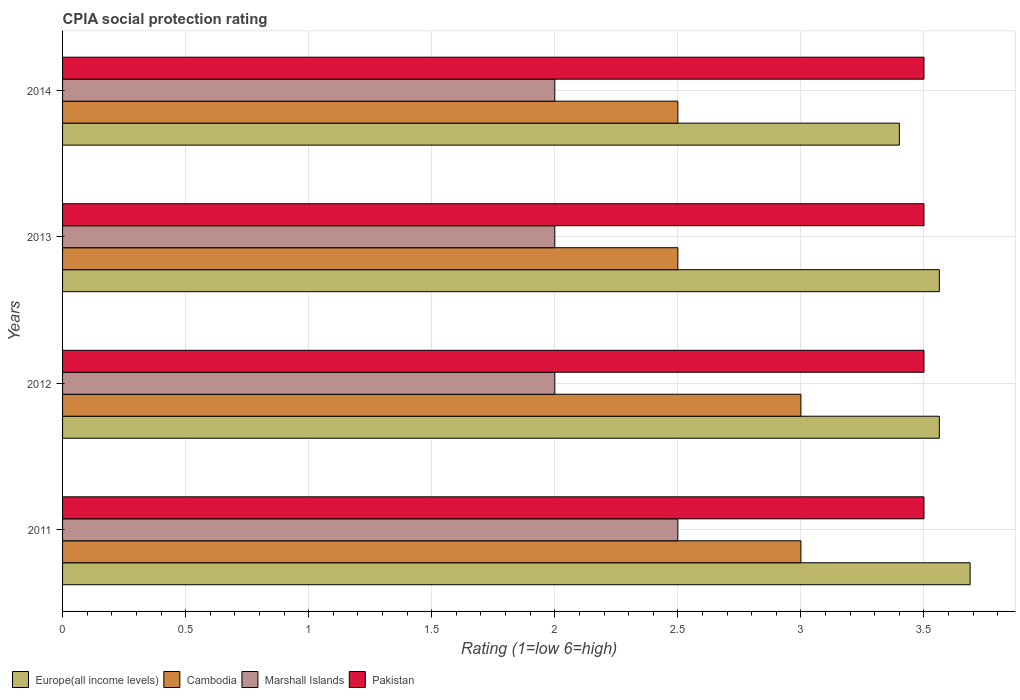How many different coloured bars are there?
Your answer should be very brief. 4. How many bars are there on the 4th tick from the top?
Your response must be concise. 4. What is the label of the 2nd group of bars from the top?
Ensure brevity in your answer.  2013. What is the CPIA rating in Cambodia in 2011?
Make the answer very short. 3. Across all years, what is the maximum CPIA rating in Cambodia?
Your answer should be compact. 3. Across all years, what is the minimum CPIA rating in Europe(all income levels)?
Offer a terse response. 3.4. In which year was the CPIA rating in Pakistan minimum?
Offer a terse response. 2011. What is the difference between the CPIA rating in Europe(all income levels) in 2013 and that in 2014?
Make the answer very short. 0.16. What is the difference between the CPIA rating in Europe(all income levels) in 2014 and the CPIA rating in Pakistan in 2013?
Offer a very short reply. -0.1. What is the average CPIA rating in Europe(all income levels) per year?
Ensure brevity in your answer.  3.55. In the year 2012, what is the difference between the CPIA rating in Europe(all income levels) and CPIA rating in Cambodia?
Offer a very short reply. 0.56. In how many years, is the CPIA rating in Pakistan greater than 2.3 ?
Ensure brevity in your answer.  4. What is the ratio of the CPIA rating in Europe(all income levels) in 2012 to that in 2014?
Make the answer very short. 1.05. Is the CPIA rating in Pakistan in 2011 less than that in 2013?
Your response must be concise. No. Is the difference between the CPIA rating in Europe(all income levels) in 2011 and 2012 greater than the difference between the CPIA rating in Cambodia in 2011 and 2012?
Offer a very short reply. Yes. What does the 3rd bar from the top in 2014 represents?
Offer a terse response. Cambodia. What does the 4th bar from the bottom in 2014 represents?
Offer a very short reply. Pakistan. Is it the case that in every year, the sum of the CPIA rating in Cambodia and CPIA rating in Marshall Islands is greater than the CPIA rating in Europe(all income levels)?
Your response must be concise. Yes. Are all the bars in the graph horizontal?
Your answer should be very brief. Yes. What is the difference between two consecutive major ticks on the X-axis?
Your answer should be compact. 0.5. Does the graph contain any zero values?
Provide a short and direct response. No. Does the graph contain grids?
Make the answer very short. Yes. How are the legend labels stacked?
Make the answer very short. Horizontal. What is the title of the graph?
Your answer should be very brief. CPIA social protection rating. Does "United Arab Emirates" appear as one of the legend labels in the graph?
Your answer should be compact. No. What is the label or title of the X-axis?
Make the answer very short. Rating (1=low 6=high). What is the Rating (1=low 6=high) of Europe(all income levels) in 2011?
Offer a very short reply. 3.69. What is the Rating (1=low 6=high) of Marshall Islands in 2011?
Provide a short and direct response. 2.5. What is the Rating (1=low 6=high) in Europe(all income levels) in 2012?
Offer a very short reply. 3.56. What is the Rating (1=low 6=high) in Pakistan in 2012?
Provide a succinct answer. 3.5. What is the Rating (1=low 6=high) of Europe(all income levels) in 2013?
Give a very brief answer. 3.56. What is the Rating (1=low 6=high) of Marshall Islands in 2013?
Offer a terse response. 2. What is the Rating (1=low 6=high) in Europe(all income levels) in 2014?
Provide a short and direct response. 3.4. What is the Rating (1=low 6=high) in Cambodia in 2014?
Make the answer very short. 2.5. Across all years, what is the maximum Rating (1=low 6=high) in Europe(all income levels)?
Provide a short and direct response. 3.69. Across all years, what is the maximum Rating (1=low 6=high) in Marshall Islands?
Ensure brevity in your answer.  2.5. Across all years, what is the minimum Rating (1=low 6=high) in Europe(all income levels)?
Offer a terse response. 3.4. Across all years, what is the minimum Rating (1=low 6=high) of Marshall Islands?
Keep it short and to the point. 2. Across all years, what is the minimum Rating (1=low 6=high) in Pakistan?
Offer a very short reply. 3.5. What is the total Rating (1=low 6=high) of Europe(all income levels) in the graph?
Make the answer very short. 14.21. What is the total Rating (1=low 6=high) in Marshall Islands in the graph?
Your response must be concise. 8.5. What is the difference between the Rating (1=low 6=high) of Marshall Islands in 2011 and that in 2012?
Offer a terse response. 0.5. What is the difference between the Rating (1=low 6=high) of Cambodia in 2011 and that in 2013?
Provide a short and direct response. 0.5. What is the difference between the Rating (1=low 6=high) in Pakistan in 2011 and that in 2013?
Keep it short and to the point. 0. What is the difference between the Rating (1=low 6=high) in Europe(all income levels) in 2011 and that in 2014?
Your answer should be compact. 0.29. What is the difference between the Rating (1=low 6=high) of Marshall Islands in 2011 and that in 2014?
Offer a very short reply. 0.5. What is the difference between the Rating (1=low 6=high) of Europe(all income levels) in 2012 and that in 2013?
Offer a very short reply. 0. What is the difference between the Rating (1=low 6=high) of Cambodia in 2012 and that in 2013?
Keep it short and to the point. 0.5. What is the difference between the Rating (1=low 6=high) in Pakistan in 2012 and that in 2013?
Your response must be concise. 0. What is the difference between the Rating (1=low 6=high) of Europe(all income levels) in 2012 and that in 2014?
Make the answer very short. 0.16. What is the difference between the Rating (1=low 6=high) in Marshall Islands in 2012 and that in 2014?
Provide a succinct answer. 0. What is the difference between the Rating (1=low 6=high) in Europe(all income levels) in 2013 and that in 2014?
Make the answer very short. 0.16. What is the difference between the Rating (1=low 6=high) of Europe(all income levels) in 2011 and the Rating (1=low 6=high) of Cambodia in 2012?
Provide a short and direct response. 0.69. What is the difference between the Rating (1=low 6=high) in Europe(all income levels) in 2011 and the Rating (1=low 6=high) in Marshall Islands in 2012?
Your response must be concise. 1.69. What is the difference between the Rating (1=low 6=high) in Europe(all income levels) in 2011 and the Rating (1=low 6=high) in Pakistan in 2012?
Your response must be concise. 0.19. What is the difference between the Rating (1=low 6=high) of Marshall Islands in 2011 and the Rating (1=low 6=high) of Pakistan in 2012?
Offer a terse response. -1. What is the difference between the Rating (1=low 6=high) of Europe(all income levels) in 2011 and the Rating (1=low 6=high) of Cambodia in 2013?
Provide a succinct answer. 1.19. What is the difference between the Rating (1=low 6=high) in Europe(all income levels) in 2011 and the Rating (1=low 6=high) in Marshall Islands in 2013?
Provide a short and direct response. 1.69. What is the difference between the Rating (1=low 6=high) in Europe(all income levels) in 2011 and the Rating (1=low 6=high) in Pakistan in 2013?
Your response must be concise. 0.19. What is the difference between the Rating (1=low 6=high) in Cambodia in 2011 and the Rating (1=low 6=high) in Marshall Islands in 2013?
Provide a short and direct response. 1. What is the difference between the Rating (1=low 6=high) in Cambodia in 2011 and the Rating (1=low 6=high) in Pakistan in 2013?
Make the answer very short. -0.5. What is the difference between the Rating (1=low 6=high) in Europe(all income levels) in 2011 and the Rating (1=low 6=high) in Cambodia in 2014?
Your response must be concise. 1.19. What is the difference between the Rating (1=low 6=high) of Europe(all income levels) in 2011 and the Rating (1=low 6=high) of Marshall Islands in 2014?
Ensure brevity in your answer.  1.69. What is the difference between the Rating (1=low 6=high) of Europe(all income levels) in 2011 and the Rating (1=low 6=high) of Pakistan in 2014?
Offer a terse response. 0.19. What is the difference between the Rating (1=low 6=high) in Europe(all income levels) in 2012 and the Rating (1=low 6=high) in Marshall Islands in 2013?
Give a very brief answer. 1.56. What is the difference between the Rating (1=low 6=high) in Europe(all income levels) in 2012 and the Rating (1=low 6=high) in Pakistan in 2013?
Make the answer very short. 0.06. What is the difference between the Rating (1=low 6=high) of Cambodia in 2012 and the Rating (1=low 6=high) of Marshall Islands in 2013?
Give a very brief answer. 1. What is the difference between the Rating (1=low 6=high) of Cambodia in 2012 and the Rating (1=low 6=high) of Pakistan in 2013?
Make the answer very short. -0.5. What is the difference between the Rating (1=low 6=high) of Marshall Islands in 2012 and the Rating (1=low 6=high) of Pakistan in 2013?
Offer a terse response. -1.5. What is the difference between the Rating (1=low 6=high) in Europe(all income levels) in 2012 and the Rating (1=low 6=high) in Marshall Islands in 2014?
Your answer should be very brief. 1.56. What is the difference between the Rating (1=low 6=high) of Europe(all income levels) in 2012 and the Rating (1=low 6=high) of Pakistan in 2014?
Provide a succinct answer. 0.06. What is the difference between the Rating (1=low 6=high) of Marshall Islands in 2012 and the Rating (1=low 6=high) of Pakistan in 2014?
Your response must be concise. -1.5. What is the difference between the Rating (1=low 6=high) in Europe(all income levels) in 2013 and the Rating (1=low 6=high) in Cambodia in 2014?
Ensure brevity in your answer.  1.06. What is the difference between the Rating (1=low 6=high) in Europe(all income levels) in 2013 and the Rating (1=low 6=high) in Marshall Islands in 2014?
Offer a terse response. 1.56. What is the difference between the Rating (1=low 6=high) in Europe(all income levels) in 2013 and the Rating (1=low 6=high) in Pakistan in 2014?
Offer a terse response. 0.06. What is the average Rating (1=low 6=high) in Europe(all income levels) per year?
Provide a succinct answer. 3.55. What is the average Rating (1=low 6=high) of Cambodia per year?
Provide a succinct answer. 2.75. What is the average Rating (1=low 6=high) of Marshall Islands per year?
Offer a very short reply. 2.12. What is the average Rating (1=low 6=high) in Pakistan per year?
Keep it short and to the point. 3.5. In the year 2011, what is the difference between the Rating (1=low 6=high) in Europe(all income levels) and Rating (1=low 6=high) in Cambodia?
Your answer should be compact. 0.69. In the year 2011, what is the difference between the Rating (1=low 6=high) in Europe(all income levels) and Rating (1=low 6=high) in Marshall Islands?
Your answer should be very brief. 1.19. In the year 2011, what is the difference between the Rating (1=low 6=high) of Europe(all income levels) and Rating (1=low 6=high) of Pakistan?
Provide a short and direct response. 0.19. In the year 2011, what is the difference between the Rating (1=low 6=high) of Cambodia and Rating (1=low 6=high) of Marshall Islands?
Provide a short and direct response. 0.5. In the year 2011, what is the difference between the Rating (1=low 6=high) of Cambodia and Rating (1=low 6=high) of Pakistan?
Make the answer very short. -0.5. In the year 2011, what is the difference between the Rating (1=low 6=high) in Marshall Islands and Rating (1=low 6=high) in Pakistan?
Provide a succinct answer. -1. In the year 2012, what is the difference between the Rating (1=low 6=high) of Europe(all income levels) and Rating (1=low 6=high) of Cambodia?
Your answer should be very brief. 0.56. In the year 2012, what is the difference between the Rating (1=low 6=high) of Europe(all income levels) and Rating (1=low 6=high) of Marshall Islands?
Make the answer very short. 1.56. In the year 2012, what is the difference between the Rating (1=low 6=high) in Europe(all income levels) and Rating (1=low 6=high) in Pakistan?
Your answer should be compact. 0.06. In the year 2012, what is the difference between the Rating (1=low 6=high) of Cambodia and Rating (1=low 6=high) of Marshall Islands?
Ensure brevity in your answer.  1. In the year 2012, what is the difference between the Rating (1=low 6=high) in Marshall Islands and Rating (1=low 6=high) in Pakistan?
Your answer should be compact. -1.5. In the year 2013, what is the difference between the Rating (1=low 6=high) of Europe(all income levels) and Rating (1=low 6=high) of Cambodia?
Keep it short and to the point. 1.06. In the year 2013, what is the difference between the Rating (1=low 6=high) of Europe(all income levels) and Rating (1=low 6=high) of Marshall Islands?
Provide a succinct answer. 1.56. In the year 2013, what is the difference between the Rating (1=low 6=high) of Europe(all income levels) and Rating (1=low 6=high) of Pakistan?
Ensure brevity in your answer.  0.06. In the year 2013, what is the difference between the Rating (1=low 6=high) in Cambodia and Rating (1=low 6=high) in Pakistan?
Provide a short and direct response. -1. In the year 2014, what is the difference between the Rating (1=low 6=high) in Europe(all income levels) and Rating (1=low 6=high) in Cambodia?
Ensure brevity in your answer.  0.9. In the year 2014, what is the difference between the Rating (1=low 6=high) of Cambodia and Rating (1=low 6=high) of Marshall Islands?
Keep it short and to the point. 0.5. In the year 2014, what is the difference between the Rating (1=low 6=high) in Marshall Islands and Rating (1=low 6=high) in Pakistan?
Keep it short and to the point. -1.5. What is the ratio of the Rating (1=low 6=high) in Europe(all income levels) in 2011 to that in 2012?
Offer a terse response. 1.04. What is the ratio of the Rating (1=low 6=high) in Cambodia in 2011 to that in 2012?
Make the answer very short. 1. What is the ratio of the Rating (1=low 6=high) in Europe(all income levels) in 2011 to that in 2013?
Give a very brief answer. 1.04. What is the ratio of the Rating (1=low 6=high) of Pakistan in 2011 to that in 2013?
Provide a short and direct response. 1. What is the ratio of the Rating (1=low 6=high) in Europe(all income levels) in 2011 to that in 2014?
Provide a short and direct response. 1.08. What is the ratio of the Rating (1=low 6=high) of Cambodia in 2011 to that in 2014?
Your answer should be compact. 1.2. What is the ratio of the Rating (1=low 6=high) of Cambodia in 2012 to that in 2013?
Your answer should be very brief. 1.2. What is the ratio of the Rating (1=low 6=high) in Marshall Islands in 2012 to that in 2013?
Provide a succinct answer. 1. What is the ratio of the Rating (1=low 6=high) of Europe(all income levels) in 2012 to that in 2014?
Ensure brevity in your answer.  1.05. What is the ratio of the Rating (1=low 6=high) in Cambodia in 2012 to that in 2014?
Your answer should be compact. 1.2. What is the ratio of the Rating (1=low 6=high) in Pakistan in 2012 to that in 2014?
Offer a very short reply. 1. What is the ratio of the Rating (1=low 6=high) in Europe(all income levels) in 2013 to that in 2014?
Make the answer very short. 1.05. What is the ratio of the Rating (1=low 6=high) of Marshall Islands in 2013 to that in 2014?
Offer a terse response. 1. What is the ratio of the Rating (1=low 6=high) of Pakistan in 2013 to that in 2014?
Your answer should be compact. 1. What is the difference between the highest and the second highest Rating (1=low 6=high) in Pakistan?
Ensure brevity in your answer.  0. What is the difference between the highest and the lowest Rating (1=low 6=high) of Europe(all income levels)?
Make the answer very short. 0.29. What is the difference between the highest and the lowest Rating (1=low 6=high) of Cambodia?
Provide a succinct answer. 0.5. What is the difference between the highest and the lowest Rating (1=low 6=high) in Marshall Islands?
Ensure brevity in your answer.  0.5. What is the difference between the highest and the lowest Rating (1=low 6=high) in Pakistan?
Keep it short and to the point. 0. 